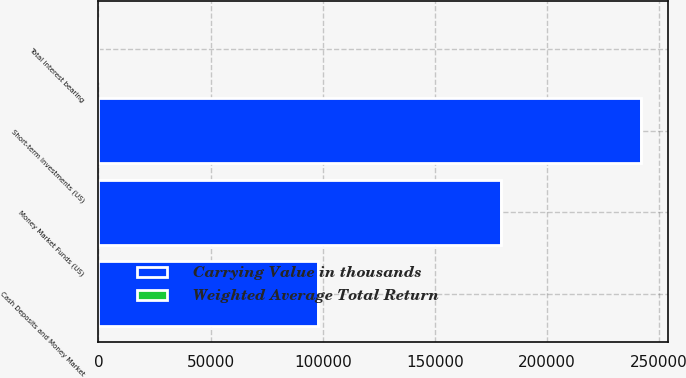Convert chart. <chart><loc_0><loc_0><loc_500><loc_500><stacked_bar_chart><ecel><fcel>Money Market Funds (US)<fcel>Short-term Investments (US)<fcel>Cash Deposits and Money Market<fcel>Total interest bearing<nl><fcel>Carrying Value in thousands<fcel>179457<fcel>241963<fcel>98008<fcel>4.08<nl><fcel>Weighted Average Total Return<fcel>3.31<fcel>4.08<fcel>3.91<fcel>3.78<nl></chart> 